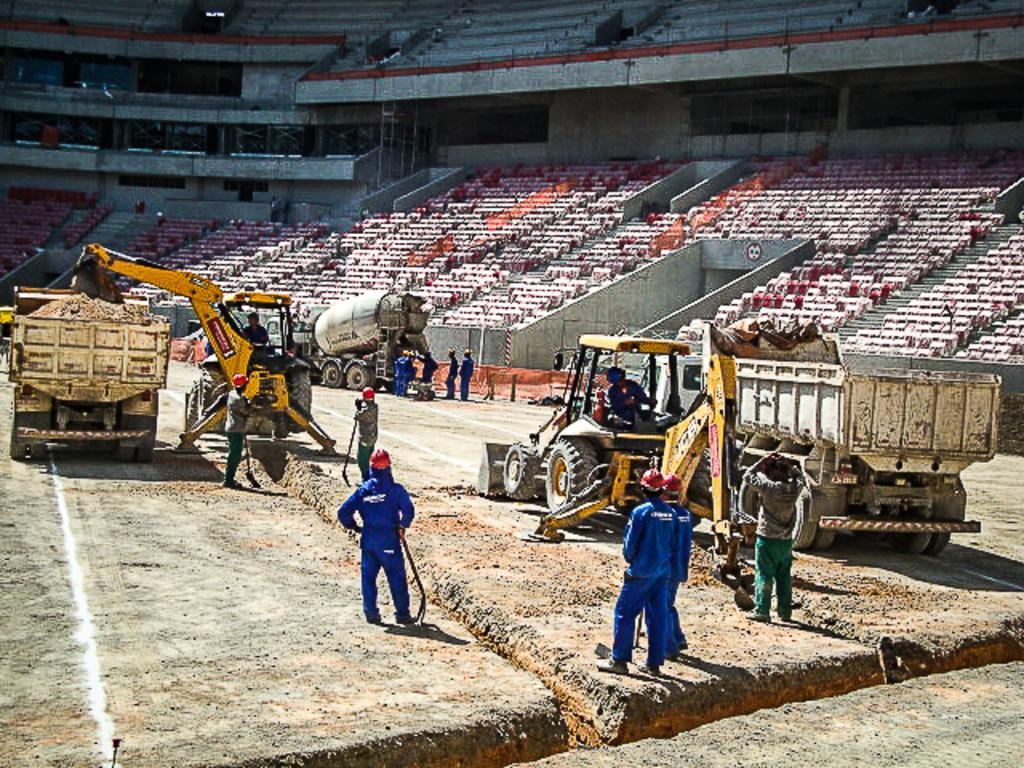What type of structure is shown in the image? There is a stadium in the image. What else can be seen in the image besides the stadium? Vehicles, people, and chairs are visible in the image. What might be used to provide illumination during events at the stadium? There are lights focused at the top of the stadium. What type of caption is written on the lunch that the people are holding in the image? There is no lunch or caption present in the image; it features a stadium with vehicles, people, chairs, and lights. 